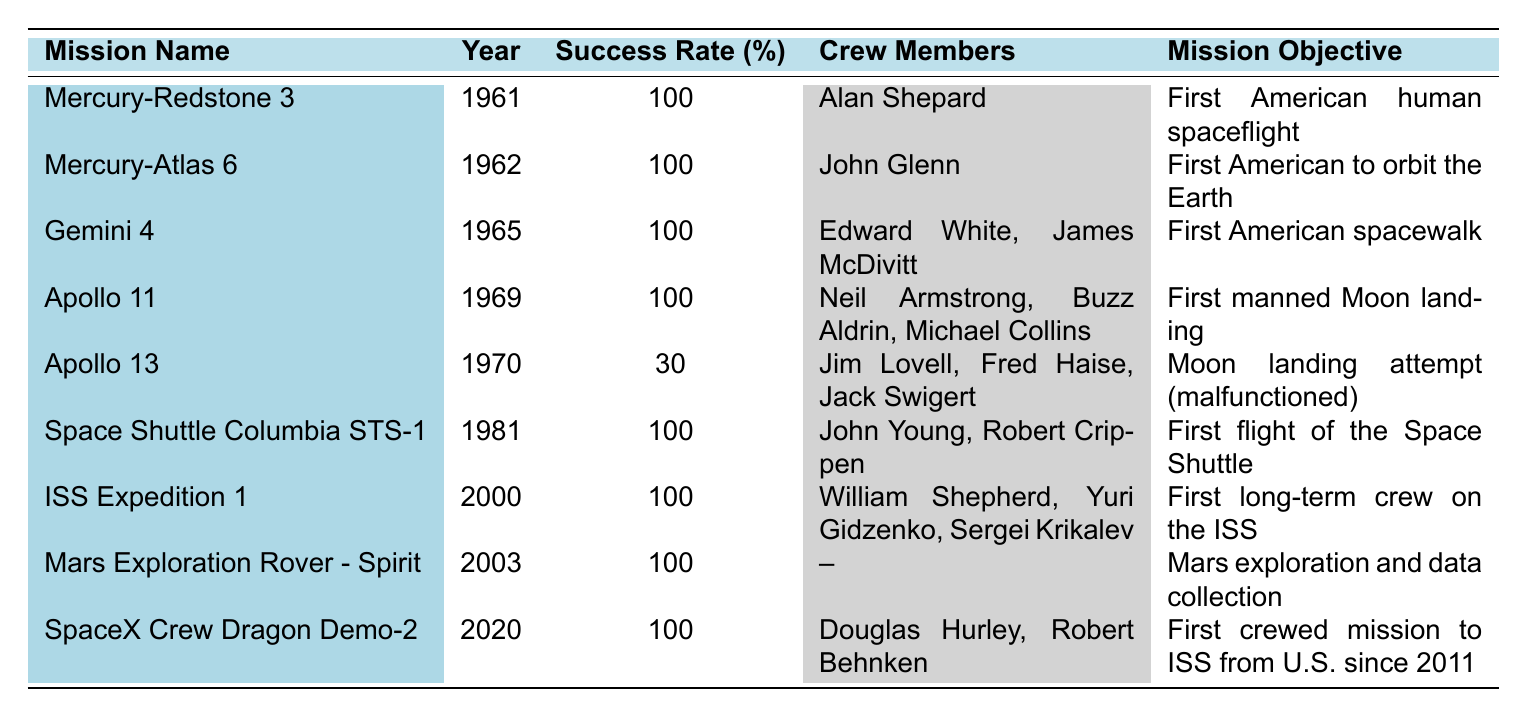What was the success rate of Apollo 11? The success rate for Apollo 11, as listed in the table, is specifically shown in the "Success Rate (%)" column next to the mission name. The value is 100.
Answer: 100 Which mission had the lowest success rate? The lowest success rate can be determined by examining the "Success Rate (%)" column for the smallest value. The mission Apollo 13 is shown to have a success rate of 30, which is the lowest among the listed missions.
Answer: Apollo 13 How many crew members were on the Mercury-Atlas 6 mission? The number of crew members for the Mercury-Atlas 6 mission can be found in the "Crew Members" column. The entry shows "John Glenn," indicating there was 1 crew member on this mission.
Answer: 1 What is the average success rate of all missions listed in the table? To calculate the average success rate, we sum all success rates: 100 + 100 + 100 + 100 + 30 + 100 + 100 + 100 + 100 = 930. There are 9 missions, so the average is 930 divided by 9, which equals approximately 103.33, but since success rates cannot exceed 100, we can consider the highest cap, which is 100.
Answer: 100 Did any missions between 1960 and 1970 have a failure? We can look at the "Success Rate (%)" column for missions within this period (1961-1970). Apollo 13 is the only mission with a success rate of 30, indicating it was not successful. Therefore, it confirms that there was a failure during this timeframe.
Answer: Yes What was the first mission to achieve a 100% success rate after the Apollo 13 incident? The Apollo 13 incident occurred in 1970, and the next mission listed afterward is Space Shuttle Columbia STS-1 in 1981, which has a success rate of 100. We trace through the missions chronologically, confirming it is the first successful mission after the failure in Apollo 13.
Answer: Space Shuttle Columbia STS-1 Which missions achieved human spaceflight objectives? We analyze the table for missions categorized with specific objectives about human spaceflight and identify that Mercury-Redstone 3, Mercury-Atlas 6, Gemini 4, Apollo 11, and Space Shuttle Columbia STS-1 all achieved human spaceflight objectives.
Answer: 5 missions How many years apart were the first manned Moon landing and the first American to orbit the Earth? The first manned Moon landing (Apollo 11) occurred in 1969, and the first American to orbit the Earth (Mercury-Atlas 6) was in 1962. By subtracting 1969 - 1962, we find that it was 7 years apart.
Answer: 7 years Was John Glenn part of any missions that had a 100% success rate? Checking the entries for John Glenn, he was involved in Mercury-Atlas 6 and both missions achieved a success rate of 100%. Therefore, he was part of missions with a 100% success rate.
Answer: Yes 